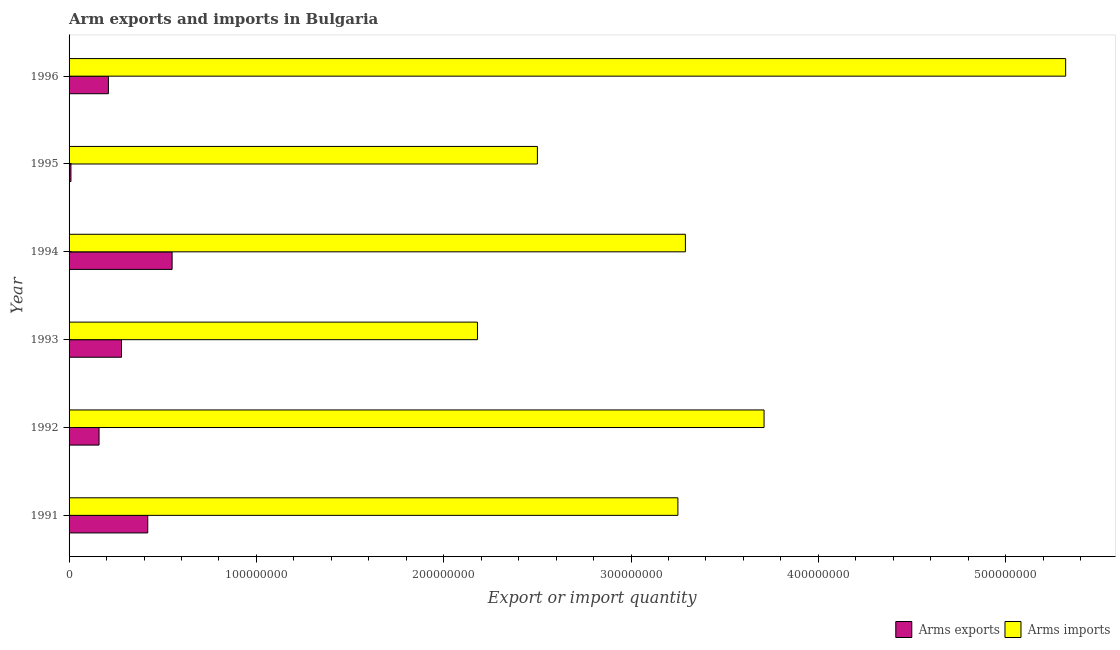How many different coloured bars are there?
Provide a succinct answer. 2. How many groups of bars are there?
Your answer should be very brief. 6. Are the number of bars on each tick of the Y-axis equal?
Provide a succinct answer. Yes. What is the arms imports in 1993?
Your response must be concise. 2.18e+08. Across all years, what is the maximum arms exports?
Your response must be concise. 5.50e+07. Across all years, what is the minimum arms imports?
Keep it short and to the point. 2.18e+08. In which year was the arms imports minimum?
Your response must be concise. 1993. What is the total arms exports in the graph?
Ensure brevity in your answer.  1.63e+08. What is the difference between the arms imports in 1991 and that in 1992?
Your answer should be very brief. -4.60e+07. What is the difference between the arms imports in 1993 and the arms exports in 1994?
Keep it short and to the point. 1.63e+08. What is the average arms exports per year?
Your response must be concise. 2.72e+07. In the year 1994, what is the difference between the arms imports and arms exports?
Offer a very short reply. 2.74e+08. Is the arms exports in 1993 less than that in 1996?
Keep it short and to the point. No. Is the difference between the arms imports in 1992 and 1994 greater than the difference between the arms exports in 1992 and 1994?
Keep it short and to the point. Yes. What is the difference between the highest and the second highest arms exports?
Ensure brevity in your answer.  1.30e+07. What is the difference between the highest and the lowest arms exports?
Provide a succinct answer. 5.40e+07. Is the sum of the arms exports in 1995 and 1996 greater than the maximum arms imports across all years?
Keep it short and to the point. No. What does the 2nd bar from the top in 1996 represents?
Ensure brevity in your answer.  Arms exports. What does the 1st bar from the bottom in 1994 represents?
Your response must be concise. Arms exports. Are all the bars in the graph horizontal?
Provide a short and direct response. Yes. Are the values on the major ticks of X-axis written in scientific E-notation?
Offer a terse response. No. Does the graph contain any zero values?
Give a very brief answer. No. How many legend labels are there?
Provide a succinct answer. 2. How are the legend labels stacked?
Offer a terse response. Horizontal. What is the title of the graph?
Keep it short and to the point. Arm exports and imports in Bulgaria. Does "Investment" appear as one of the legend labels in the graph?
Provide a succinct answer. No. What is the label or title of the X-axis?
Ensure brevity in your answer.  Export or import quantity. What is the label or title of the Y-axis?
Keep it short and to the point. Year. What is the Export or import quantity of Arms exports in 1991?
Make the answer very short. 4.20e+07. What is the Export or import quantity in Arms imports in 1991?
Give a very brief answer. 3.25e+08. What is the Export or import quantity in Arms exports in 1992?
Give a very brief answer. 1.60e+07. What is the Export or import quantity of Arms imports in 1992?
Offer a very short reply. 3.71e+08. What is the Export or import quantity of Arms exports in 1993?
Keep it short and to the point. 2.80e+07. What is the Export or import quantity of Arms imports in 1993?
Provide a short and direct response. 2.18e+08. What is the Export or import quantity in Arms exports in 1994?
Offer a terse response. 5.50e+07. What is the Export or import quantity in Arms imports in 1994?
Your response must be concise. 3.29e+08. What is the Export or import quantity in Arms imports in 1995?
Offer a very short reply. 2.50e+08. What is the Export or import quantity in Arms exports in 1996?
Make the answer very short. 2.10e+07. What is the Export or import quantity in Arms imports in 1996?
Keep it short and to the point. 5.32e+08. Across all years, what is the maximum Export or import quantity in Arms exports?
Offer a terse response. 5.50e+07. Across all years, what is the maximum Export or import quantity of Arms imports?
Offer a terse response. 5.32e+08. Across all years, what is the minimum Export or import quantity of Arms imports?
Keep it short and to the point. 2.18e+08. What is the total Export or import quantity in Arms exports in the graph?
Your answer should be compact. 1.63e+08. What is the total Export or import quantity in Arms imports in the graph?
Your response must be concise. 2.02e+09. What is the difference between the Export or import quantity in Arms exports in 1991 and that in 1992?
Provide a short and direct response. 2.60e+07. What is the difference between the Export or import quantity of Arms imports in 1991 and that in 1992?
Your answer should be very brief. -4.60e+07. What is the difference between the Export or import quantity of Arms exports in 1991 and that in 1993?
Ensure brevity in your answer.  1.40e+07. What is the difference between the Export or import quantity of Arms imports in 1991 and that in 1993?
Ensure brevity in your answer.  1.07e+08. What is the difference between the Export or import quantity of Arms exports in 1991 and that in 1994?
Your response must be concise. -1.30e+07. What is the difference between the Export or import quantity of Arms exports in 1991 and that in 1995?
Ensure brevity in your answer.  4.10e+07. What is the difference between the Export or import quantity in Arms imports in 1991 and that in 1995?
Keep it short and to the point. 7.50e+07. What is the difference between the Export or import quantity of Arms exports in 1991 and that in 1996?
Your answer should be very brief. 2.10e+07. What is the difference between the Export or import quantity of Arms imports in 1991 and that in 1996?
Provide a short and direct response. -2.07e+08. What is the difference between the Export or import quantity of Arms exports in 1992 and that in 1993?
Keep it short and to the point. -1.20e+07. What is the difference between the Export or import quantity in Arms imports in 1992 and that in 1993?
Your answer should be very brief. 1.53e+08. What is the difference between the Export or import quantity of Arms exports in 1992 and that in 1994?
Keep it short and to the point. -3.90e+07. What is the difference between the Export or import quantity in Arms imports in 1992 and that in 1994?
Offer a terse response. 4.20e+07. What is the difference between the Export or import quantity of Arms exports in 1992 and that in 1995?
Ensure brevity in your answer.  1.50e+07. What is the difference between the Export or import quantity in Arms imports in 1992 and that in 1995?
Your answer should be compact. 1.21e+08. What is the difference between the Export or import quantity in Arms exports in 1992 and that in 1996?
Provide a succinct answer. -5.00e+06. What is the difference between the Export or import quantity of Arms imports in 1992 and that in 1996?
Your response must be concise. -1.61e+08. What is the difference between the Export or import quantity in Arms exports in 1993 and that in 1994?
Ensure brevity in your answer.  -2.70e+07. What is the difference between the Export or import quantity of Arms imports in 1993 and that in 1994?
Your response must be concise. -1.11e+08. What is the difference between the Export or import quantity in Arms exports in 1993 and that in 1995?
Keep it short and to the point. 2.70e+07. What is the difference between the Export or import quantity of Arms imports in 1993 and that in 1995?
Provide a succinct answer. -3.20e+07. What is the difference between the Export or import quantity of Arms imports in 1993 and that in 1996?
Offer a very short reply. -3.14e+08. What is the difference between the Export or import quantity in Arms exports in 1994 and that in 1995?
Offer a very short reply. 5.40e+07. What is the difference between the Export or import quantity in Arms imports in 1994 and that in 1995?
Give a very brief answer. 7.90e+07. What is the difference between the Export or import quantity in Arms exports in 1994 and that in 1996?
Offer a terse response. 3.40e+07. What is the difference between the Export or import quantity of Arms imports in 1994 and that in 1996?
Your answer should be compact. -2.03e+08. What is the difference between the Export or import quantity of Arms exports in 1995 and that in 1996?
Make the answer very short. -2.00e+07. What is the difference between the Export or import quantity in Arms imports in 1995 and that in 1996?
Your answer should be compact. -2.82e+08. What is the difference between the Export or import quantity of Arms exports in 1991 and the Export or import quantity of Arms imports in 1992?
Make the answer very short. -3.29e+08. What is the difference between the Export or import quantity of Arms exports in 1991 and the Export or import quantity of Arms imports in 1993?
Make the answer very short. -1.76e+08. What is the difference between the Export or import quantity in Arms exports in 1991 and the Export or import quantity in Arms imports in 1994?
Make the answer very short. -2.87e+08. What is the difference between the Export or import quantity of Arms exports in 1991 and the Export or import quantity of Arms imports in 1995?
Your answer should be very brief. -2.08e+08. What is the difference between the Export or import quantity of Arms exports in 1991 and the Export or import quantity of Arms imports in 1996?
Ensure brevity in your answer.  -4.90e+08. What is the difference between the Export or import quantity in Arms exports in 1992 and the Export or import quantity in Arms imports in 1993?
Provide a short and direct response. -2.02e+08. What is the difference between the Export or import quantity in Arms exports in 1992 and the Export or import quantity in Arms imports in 1994?
Give a very brief answer. -3.13e+08. What is the difference between the Export or import quantity in Arms exports in 1992 and the Export or import quantity in Arms imports in 1995?
Offer a very short reply. -2.34e+08. What is the difference between the Export or import quantity of Arms exports in 1992 and the Export or import quantity of Arms imports in 1996?
Make the answer very short. -5.16e+08. What is the difference between the Export or import quantity in Arms exports in 1993 and the Export or import quantity in Arms imports in 1994?
Offer a terse response. -3.01e+08. What is the difference between the Export or import quantity of Arms exports in 1993 and the Export or import quantity of Arms imports in 1995?
Provide a succinct answer. -2.22e+08. What is the difference between the Export or import quantity in Arms exports in 1993 and the Export or import quantity in Arms imports in 1996?
Keep it short and to the point. -5.04e+08. What is the difference between the Export or import quantity in Arms exports in 1994 and the Export or import quantity in Arms imports in 1995?
Provide a succinct answer. -1.95e+08. What is the difference between the Export or import quantity of Arms exports in 1994 and the Export or import quantity of Arms imports in 1996?
Make the answer very short. -4.77e+08. What is the difference between the Export or import quantity in Arms exports in 1995 and the Export or import quantity in Arms imports in 1996?
Make the answer very short. -5.31e+08. What is the average Export or import quantity of Arms exports per year?
Ensure brevity in your answer.  2.72e+07. What is the average Export or import quantity in Arms imports per year?
Offer a very short reply. 3.38e+08. In the year 1991, what is the difference between the Export or import quantity of Arms exports and Export or import quantity of Arms imports?
Your answer should be compact. -2.83e+08. In the year 1992, what is the difference between the Export or import quantity of Arms exports and Export or import quantity of Arms imports?
Give a very brief answer. -3.55e+08. In the year 1993, what is the difference between the Export or import quantity of Arms exports and Export or import quantity of Arms imports?
Your answer should be compact. -1.90e+08. In the year 1994, what is the difference between the Export or import quantity of Arms exports and Export or import quantity of Arms imports?
Your response must be concise. -2.74e+08. In the year 1995, what is the difference between the Export or import quantity in Arms exports and Export or import quantity in Arms imports?
Offer a terse response. -2.49e+08. In the year 1996, what is the difference between the Export or import quantity of Arms exports and Export or import quantity of Arms imports?
Your response must be concise. -5.11e+08. What is the ratio of the Export or import quantity in Arms exports in 1991 to that in 1992?
Make the answer very short. 2.62. What is the ratio of the Export or import quantity of Arms imports in 1991 to that in 1992?
Your answer should be compact. 0.88. What is the ratio of the Export or import quantity in Arms imports in 1991 to that in 1993?
Provide a short and direct response. 1.49. What is the ratio of the Export or import quantity in Arms exports in 1991 to that in 1994?
Ensure brevity in your answer.  0.76. What is the ratio of the Export or import quantity in Arms imports in 1991 to that in 1994?
Give a very brief answer. 0.99. What is the ratio of the Export or import quantity in Arms exports in 1991 to that in 1995?
Keep it short and to the point. 42. What is the ratio of the Export or import quantity of Arms imports in 1991 to that in 1995?
Provide a succinct answer. 1.3. What is the ratio of the Export or import quantity in Arms exports in 1991 to that in 1996?
Offer a terse response. 2. What is the ratio of the Export or import quantity of Arms imports in 1991 to that in 1996?
Offer a very short reply. 0.61. What is the ratio of the Export or import quantity of Arms exports in 1992 to that in 1993?
Ensure brevity in your answer.  0.57. What is the ratio of the Export or import quantity of Arms imports in 1992 to that in 1993?
Offer a very short reply. 1.7. What is the ratio of the Export or import quantity in Arms exports in 1992 to that in 1994?
Make the answer very short. 0.29. What is the ratio of the Export or import quantity in Arms imports in 1992 to that in 1994?
Offer a terse response. 1.13. What is the ratio of the Export or import quantity of Arms exports in 1992 to that in 1995?
Provide a succinct answer. 16. What is the ratio of the Export or import quantity of Arms imports in 1992 to that in 1995?
Make the answer very short. 1.48. What is the ratio of the Export or import quantity of Arms exports in 1992 to that in 1996?
Offer a terse response. 0.76. What is the ratio of the Export or import quantity of Arms imports in 1992 to that in 1996?
Your answer should be very brief. 0.7. What is the ratio of the Export or import quantity in Arms exports in 1993 to that in 1994?
Your answer should be compact. 0.51. What is the ratio of the Export or import quantity in Arms imports in 1993 to that in 1994?
Make the answer very short. 0.66. What is the ratio of the Export or import quantity of Arms imports in 1993 to that in 1995?
Give a very brief answer. 0.87. What is the ratio of the Export or import quantity in Arms exports in 1993 to that in 1996?
Give a very brief answer. 1.33. What is the ratio of the Export or import quantity of Arms imports in 1993 to that in 1996?
Provide a short and direct response. 0.41. What is the ratio of the Export or import quantity of Arms imports in 1994 to that in 1995?
Your answer should be very brief. 1.32. What is the ratio of the Export or import quantity of Arms exports in 1994 to that in 1996?
Provide a short and direct response. 2.62. What is the ratio of the Export or import quantity in Arms imports in 1994 to that in 1996?
Offer a terse response. 0.62. What is the ratio of the Export or import quantity of Arms exports in 1995 to that in 1996?
Offer a terse response. 0.05. What is the ratio of the Export or import quantity of Arms imports in 1995 to that in 1996?
Provide a short and direct response. 0.47. What is the difference between the highest and the second highest Export or import quantity in Arms exports?
Give a very brief answer. 1.30e+07. What is the difference between the highest and the second highest Export or import quantity in Arms imports?
Give a very brief answer. 1.61e+08. What is the difference between the highest and the lowest Export or import quantity in Arms exports?
Your answer should be compact. 5.40e+07. What is the difference between the highest and the lowest Export or import quantity of Arms imports?
Your response must be concise. 3.14e+08. 